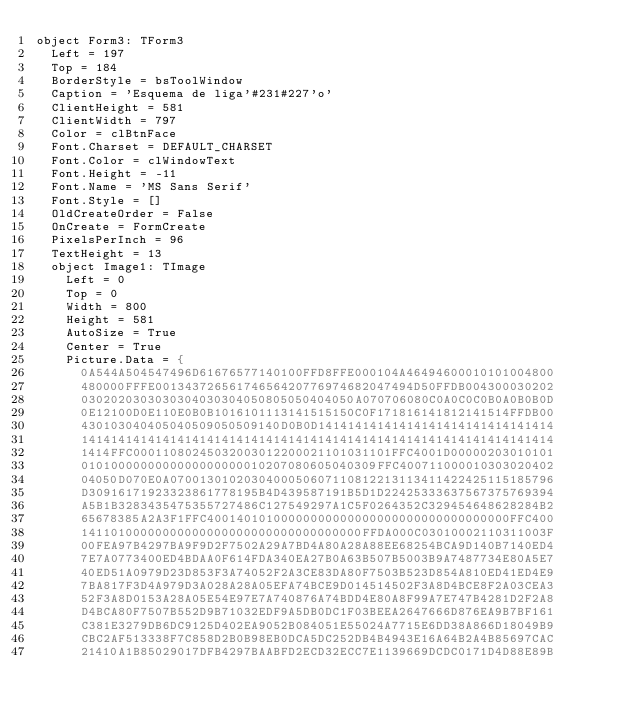Convert code to text. <code><loc_0><loc_0><loc_500><loc_500><_Pascal_>object Form3: TForm3
  Left = 197
  Top = 184
  BorderStyle = bsToolWindow
  Caption = 'Esquema de liga'#231#227'o'
  ClientHeight = 581
  ClientWidth = 797
  Color = clBtnFace
  Font.Charset = DEFAULT_CHARSET
  Font.Color = clWindowText
  Font.Height = -11
  Font.Name = 'MS Sans Serif'
  Font.Style = []
  OldCreateOrder = False
  OnCreate = FormCreate
  PixelsPerInch = 96
  TextHeight = 13
  object Image1: TImage
    Left = 0
    Top = 0
    Width = 800
    Height = 581
    AutoSize = True
    Center = True
    Picture.Data = {
      0A544A504547496D61676577140100FFD8FFE000104A46494600010101004800
      480000FFFE00134372656174656420776974682047494D50FFDB004300030202
      0302020303030304030304050805050404050A070706080C0A0C0C0B0A0B0B0D
      0E12100D0E110E0B0B1016101113141515150C0F171816141812141514FFDB00
      430103040405040509050509140D0B0D14141414141414141414141414141414
      1414141414141414141414141414141414141414141414141414141414141414
      1414FFC00011080245032003012200021101031101FFC4001D00000203010101
      0101000000000000000000010207080605040309FFC400711000010303020402
      04050D070E0A0700130102030400050607110812213113411422425115185796
      D30916171923323861778195B4D439587191B5D1D22425333637567375769394
      A5B1B3283435475355727486C127549297A1C5F0264352C329454648628284B2
      65678385A2A3F1FFC40014010100000000000000000000000000000000FFC400
      14110100000000000000000000000000000000FFDA000C03010002110311003F
      00FEA97B4297BA9F9D2F7502A29A7BD4A80A28A88EE68254BCA9D140B7140ED4
      7E7A0773400ED4BDAA0F614FDA340EA27B0A63B507B5003B9A7487734E80A5E7
      40ED51A0979D23D853F3A74052F2A3CE83DA80F7503B523D854A810ED41ED4E9
      7BA817F3D4A979D3A028A28A05EFA74BCE9D014514502F3A8D4BCE8F2A03CEA3
      52F3A8D0153A28A05E54E97E7A740876A74BDD4E80A8F99A7E747B4281D2F2A8
      D4BCA80F7507B552D9B71032EDF9A5DB0DC1F03BEEA2647666D876EA9B7BF161
      C381E3279DB6DC9125D402EA9052B084051E55024A7715E6DD38A866D18049B9
      CBC2AF513338F7C858D2B0B98EB0DCA5DC252DB4B4943E16A64B2A4B85697CAC
      21410A1B85029017DFB4297BAABFD2ECD32ECC7E1139669DCDC0171D4D88E89B</code> 